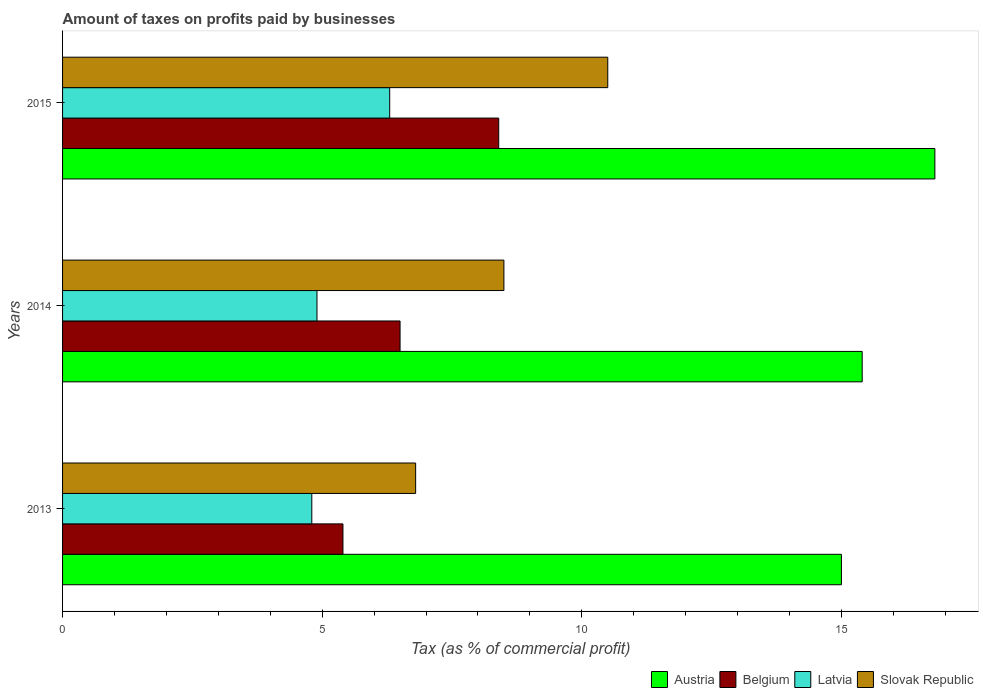Are the number of bars on each tick of the Y-axis equal?
Ensure brevity in your answer.  Yes. How many bars are there on the 3rd tick from the top?
Offer a very short reply. 4. Across all years, what is the minimum percentage of taxes paid by businesses in Belgium?
Your answer should be compact. 5.4. In which year was the percentage of taxes paid by businesses in Latvia maximum?
Provide a short and direct response. 2015. In which year was the percentage of taxes paid by businesses in Slovak Republic minimum?
Provide a succinct answer. 2013. What is the total percentage of taxes paid by businesses in Belgium in the graph?
Offer a terse response. 20.3. What is the difference between the percentage of taxes paid by businesses in Slovak Republic in 2013 and that in 2015?
Your answer should be very brief. -3.7. What is the difference between the percentage of taxes paid by businesses in Slovak Republic in 2013 and the percentage of taxes paid by businesses in Latvia in 2015?
Give a very brief answer. 0.5. What is the average percentage of taxes paid by businesses in Austria per year?
Provide a succinct answer. 15.73. In the year 2015, what is the difference between the percentage of taxes paid by businesses in Slovak Republic and percentage of taxes paid by businesses in Latvia?
Provide a succinct answer. 4.2. What is the ratio of the percentage of taxes paid by businesses in Belgium in 2013 to that in 2015?
Make the answer very short. 0.64. Is the percentage of taxes paid by businesses in Belgium in 2013 less than that in 2015?
Provide a succinct answer. Yes. What is the difference between the highest and the second highest percentage of taxes paid by businesses in Latvia?
Ensure brevity in your answer.  1.4. In how many years, is the percentage of taxes paid by businesses in Belgium greater than the average percentage of taxes paid by businesses in Belgium taken over all years?
Provide a short and direct response. 1. Is it the case that in every year, the sum of the percentage of taxes paid by businesses in Slovak Republic and percentage of taxes paid by businesses in Austria is greater than the sum of percentage of taxes paid by businesses in Latvia and percentage of taxes paid by businesses in Belgium?
Provide a succinct answer. Yes. What does the 3rd bar from the top in 2014 represents?
Your answer should be very brief. Belgium. What does the 1st bar from the bottom in 2015 represents?
Ensure brevity in your answer.  Austria. What is the difference between two consecutive major ticks on the X-axis?
Provide a short and direct response. 5. Are the values on the major ticks of X-axis written in scientific E-notation?
Provide a short and direct response. No. Does the graph contain grids?
Offer a terse response. No. How are the legend labels stacked?
Provide a short and direct response. Horizontal. What is the title of the graph?
Your answer should be very brief. Amount of taxes on profits paid by businesses. Does "Uzbekistan" appear as one of the legend labels in the graph?
Keep it short and to the point. No. What is the label or title of the X-axis?
Your answer should be compact. Tax (as % of commercial profit). What is the label or title of the Y-axis?
Provide a short and direct response. Years. What is the Tax (as % of commercial profit) in Austria in 2013?
Your answer should be compact. 15. What is the Tax (as % of commercial profit) of Slovak Republic in 2013?
Offer a terse response. 6.8. What is the Tax (as % of commercial profit) of Austria in 2014?
Ensure brevity in your answer.  15.4. What is the Tax (as % of commercial profit) in Belgium in 2014?
Keep it short and to the point. 6.5. What is the Tax (as % of commercial profit) in Latvia in 2014?
Make the answer very short. 4.9. What is the Tax (as % of commercial profit) of Slovak Republic in 2014?
Your response must be concise. 8.5. What is the Tax (as % of commercial profit) of Austria in 2015?
Ensure brevity in your answer.  16.8. What is the Tax (as % of commercial profit) in Slovak Republic in 2015?
Offer a very short reply. 10.5. Across all years, what is the maximum Tax (as % of commercial profit) of Belgium?
Give a very brief answer. 8.4. Across all years, what is the maximum Tax (as % of commercial profit) of Latvia?
Offer a terse response. 6.3. What is the total Tax (as % of commercial profit) of Austria in the graph?
Your response must be concise. 47.2. What is the total Tax (as % of commercial profit) of Belgium in the graph?
Ensure brevity in your answer.  20.3. What is the total Tax (as % of commercial profit) of Slovak Republic in the graph?
Your response must be concise. 25.8. What is the difference between the Tax (as % of commercial profit) in Belgium in 2013 and that in 2014?
Give a very brief answer. -1.1. What is the difference between the Tax (as % of commercial profit) in Latvia in 2013 and that in 2015?
Provide a short and direct response. -1.5. What is the difference between the Tax (as % of commercial profit) in Slovak Republic in 2013 and that in 2015?
Keep it short and to the point. -3.7. What is the difference between the Tax (as % of commercial profit) in Austria in 2014 and that in 2015?
Your answer should be compact. -1.4. What is the difference between the Tax (as % of commercial profit) of Belgium in 2014 and that in 2015?
Give a very brief answer. -1.9. What is the difference between the Tax (as % of commercial profit) of Slovak Republic in 2014 and that in 2015?
Your response must be concise. -2. What is the difference between the Tax (as % of commercial profit) of Austria in 2013 and the Tax (as % of commercial profit) of Belgium in 2014?
Your response must be concise. 8.5. What is the difference between the Tax (as % of commercial profit) in Austria in 2013 and the Tax (as % of commercial profit) in Belgium in 2015?
Make the answer very short. 6.6. What is the difference between the Tax (as % of commercial profit) in Austria in 2013 and the Tax (as % of commercial profit) in Slovak Republic in 2015?
Ensure brevity in your answer.  4.5. What is the difference between the Tax (as % of commercial profit) in Belgium in 2013 and the Tax (as % of commercial profit) in Latvia in 2015?
Provide a succinct answer. -0.9. What is the difference between the Tax (as % of commercial profit) of Austria in 2014 and the Tax (as % of commercial profit) of Slovak Republic in 2015?
Provide a succinct answer. 4.9. What is the difference between the Tax (as % of commercial profit) in Latvia in 2014 and the Tax (as % of commercial profit) in Slovak Republic in 2015?
Provide a short and direct response. -5.6. What is the average Tax (as % of commercial profit) in Austria per year?
Keep it short and to the point. 15.73. What is the average Tax (as % of commercial profit) in Belgium per year?
Provide a succinct answer. 6.77. What is the average Tax (as % of commercial profit) of Latvia per year?
Keep it short and to the point. 5.33. In the year 2013, what is the difference between the Tax (as % of commercial profit) of Austria and Tax (as % of commercial profit) of Belgium?
Make the answer very short. 9.6. In the year 2013, what is the difference between the Tax (as % of commercial profit) in Austria and Tax (as % of commercial profit) in Latvia?
Make the answer very short. 10.2. In the year 2014, what is the difference between the Tax (as % of commercial profit) in Austria and Tax (as % of commercial profit) in Belgium?
Give a very brief answer. 8.9. In the year 2014, what is the difference between the Tax (as % of commercial profit) in Austria and Tax (as % of commercial profit) in Latvia?
Make the answer very short. 10.5. In the year 2014, what is the difference between the Tax (as % of commercial profit) of Belgium and Tax (as % of commercial profit) of Latvia?
Offer a very short reply. 1.6. In the year 2014, what is the difference between the Tax (as % of commercial profit) in Belgium and Tax (as % of commercial profit) in Slovak Republic?
Your response must be concise. -2. In the year 2014, what is the difference between the Tax (as % of commercial profit) in Latvia and Tax (as % of commercial profit) in Slovak Republic?
Ensure brevity in your answer.  -3.6. In the year 2015, what is the difference between the Tax (as % of commercial profit) in Austria and Tax (as % of commercial profit) in Belgium?
Ensure brevity in your answer.  8.4. In the year 2015, what is the difference between the Tax (as % of commercial profit) in Belgium and Tax (as % of commercial profit) in Slovak Republic?
Make the answer very short. -2.1. In the year 2015, what is the difference between the Tax (as % of commercial profit) of Latvia and Tax (as % of commercial profit) of Slovak Republic?
Ensure brevity in your answer.  -4.2. What is the ratio of the Tax (as % of commercial profit) of Austria in 2013 to that in 2014?
Offer a terse response. 0.97. What is the ratio of the Tax (as % of commercial profit) in Belgium in 2013 to that in 2014?
Offer a very short reply. 0.83. What is the ratio of the Tax (as % of commercial profit) of Latvia in 2013 to that in 2014?
Make the answer very short. 0.98. What is the ratio of the Tax (as % of commercial profit) in Slovak Republic in 2013 to that in 2014?
Your answer should be very brief. 0.8. What is the ratio of the Tax (as % of commercial profit) of Austria in 2013 to that in 2015?
Your answer should be compact. 0.89. What is the ratio of the Tax (as % of commercial profit) in Belgium in 2013 to that in 2015?
Give a very brief answer. 0.64. What is the ratio of the Tax (as % of commercial profit) in Latvia in 2013 to that in 2015?
Provide a short and direct response. 0.76. What is the ratio of the Tax (as % of commercial profit) of Slovak Republic in 2013 to that in 2015?
Make the answer very short. 0.65. What is the ratio of the Tax (as % of commercial profit) of Austria in 2014 to that in 2015?
Ensure brevity in your answer.  0.92. What is the ratio of the Tax (as % of commercial profit) in Belgium in 2014 to that in 2015?
Ensure brevity in your answer.  0.77. What is the ratio of the Tax (as % of commercial profit) in Slovak Republic in 2014 to that in 2015?
Offer a terse response. 0.81. What is the difference between the highest and the second highest Tax (as % of commercial profit) of Austria?
Keep it short and to the point. 1.4. What is the difference between the highest and the lowest Tax (as % of commercial profit) in Austria?
Make the answer very short. 1.8. What is the difference between the highest and the lowest Tax (as % of commercial profit) in Belgium?
Provide a succinct answer. 3. What is the difference between the highest and the lowest Tax (as % of commercial profit) in Slovak Republic?
Your answer should be compact. 3.7. 